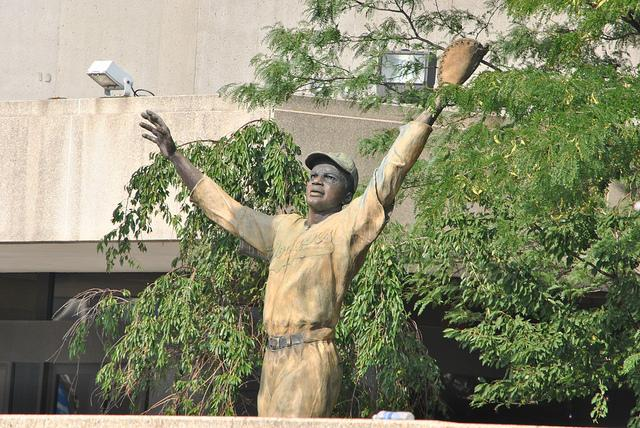What is the statue wearing?

Choices:
A) tiara
B) gas mask
C) crown
D) belt belt 